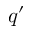Convert formula to latex. <formula><loc_0><loc_0><loc_500><loc_500>q ^ { \prime }</formula> 